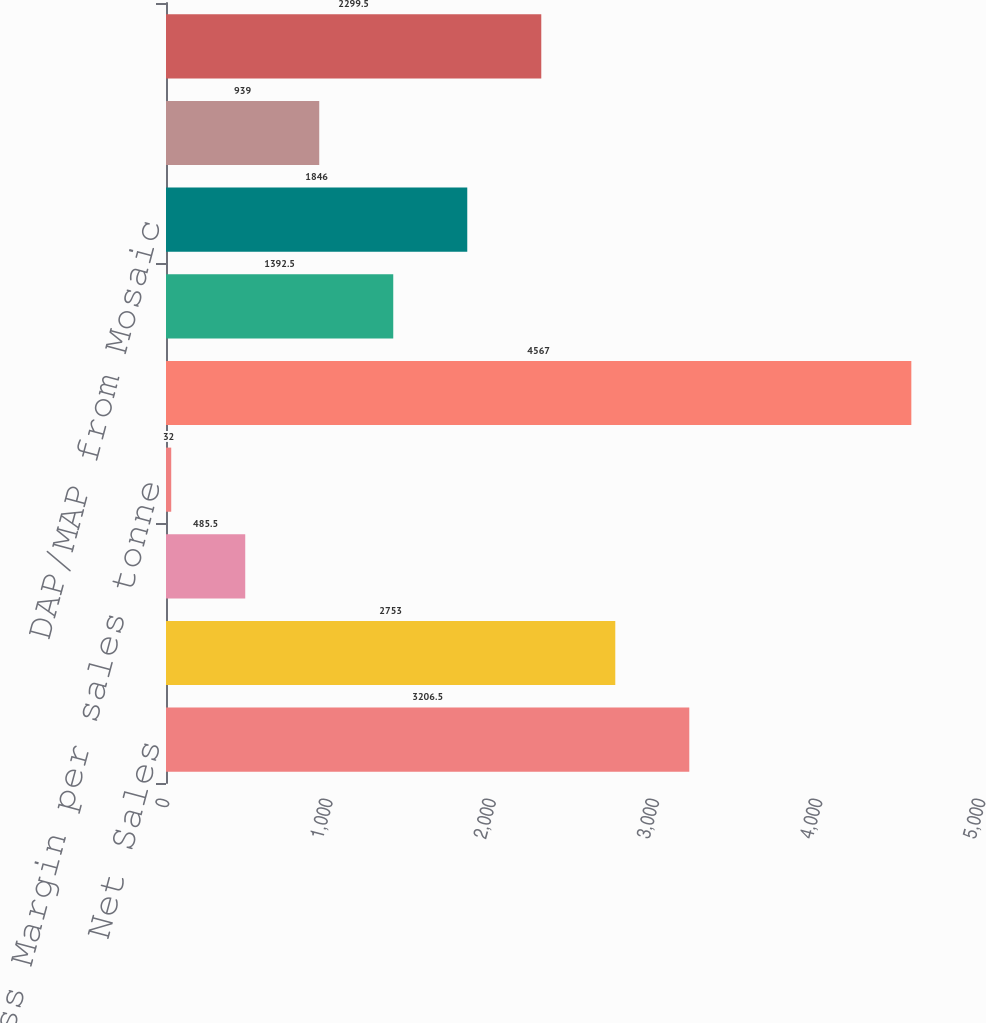Convert chart to OTSL. <chart><loc_0><loc_0><loc_500><loc_500><bar_chart><fcel>Net Sales<fcel>Cost of goods sold<fcel>Gross margin<fcel>Gross Margin per sales tonne<fcel>Sales volume (in thousands of<fcel>Average selling price (FOB<fcel>DAP/MAP from Mosaic<fcel>MicroEssentials ® from Mosaic<fcel>Potash from Mosaic/Canpotex<nl><fcel>3206.5<fcel>2753<fcel>485.5<fcel>32<fcel>4567<fcel>1392.5<fcel>1846<fcel>939<fcel>2299.5<nl></chart> 